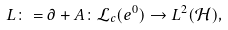Convert formula to latex. <formula><loc_0><loc_0><loc_500><loc_500>L \colon = \partial + A \colon \mathcal { L } _ { c } ( e ^ { 0 } ) \to L ^ { 2 } ( \mathcal { H } ) ,</formula> 